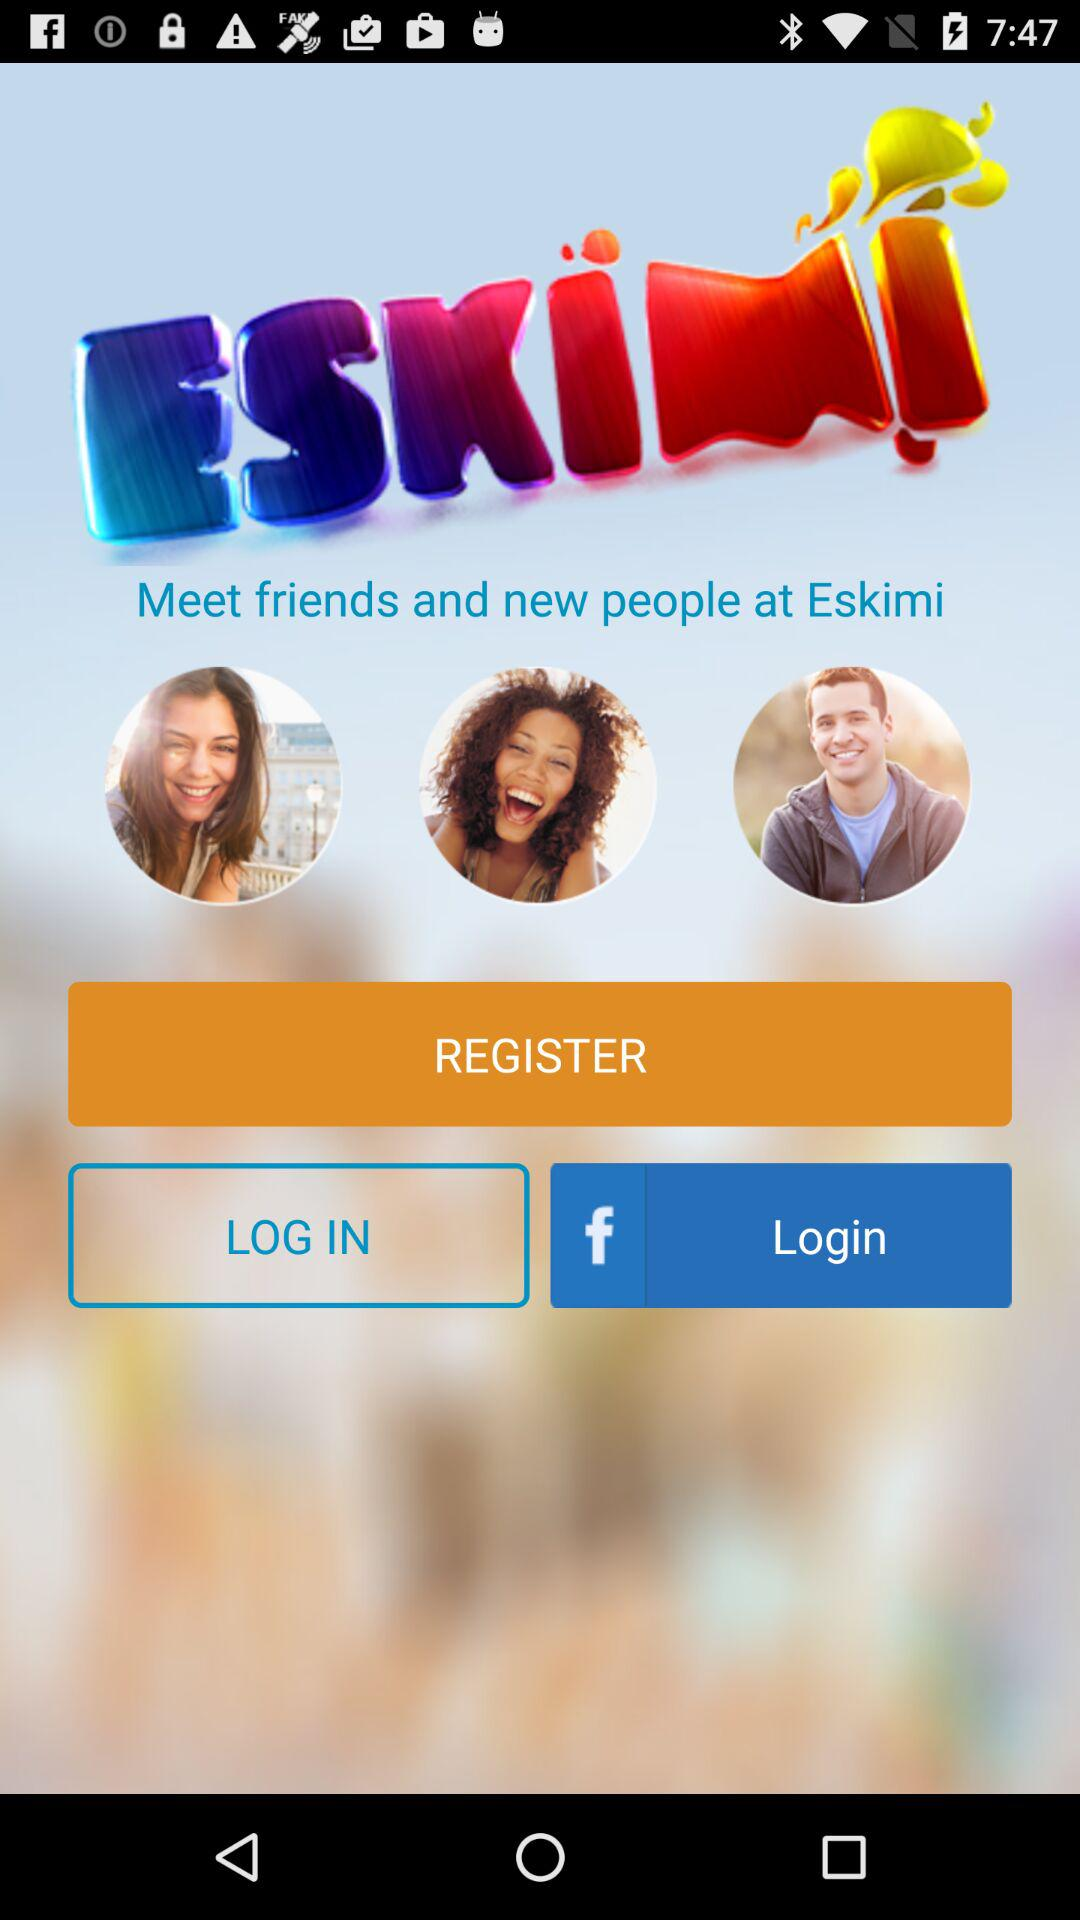What is the name of the application? The name of the application is "ESKIMI". 